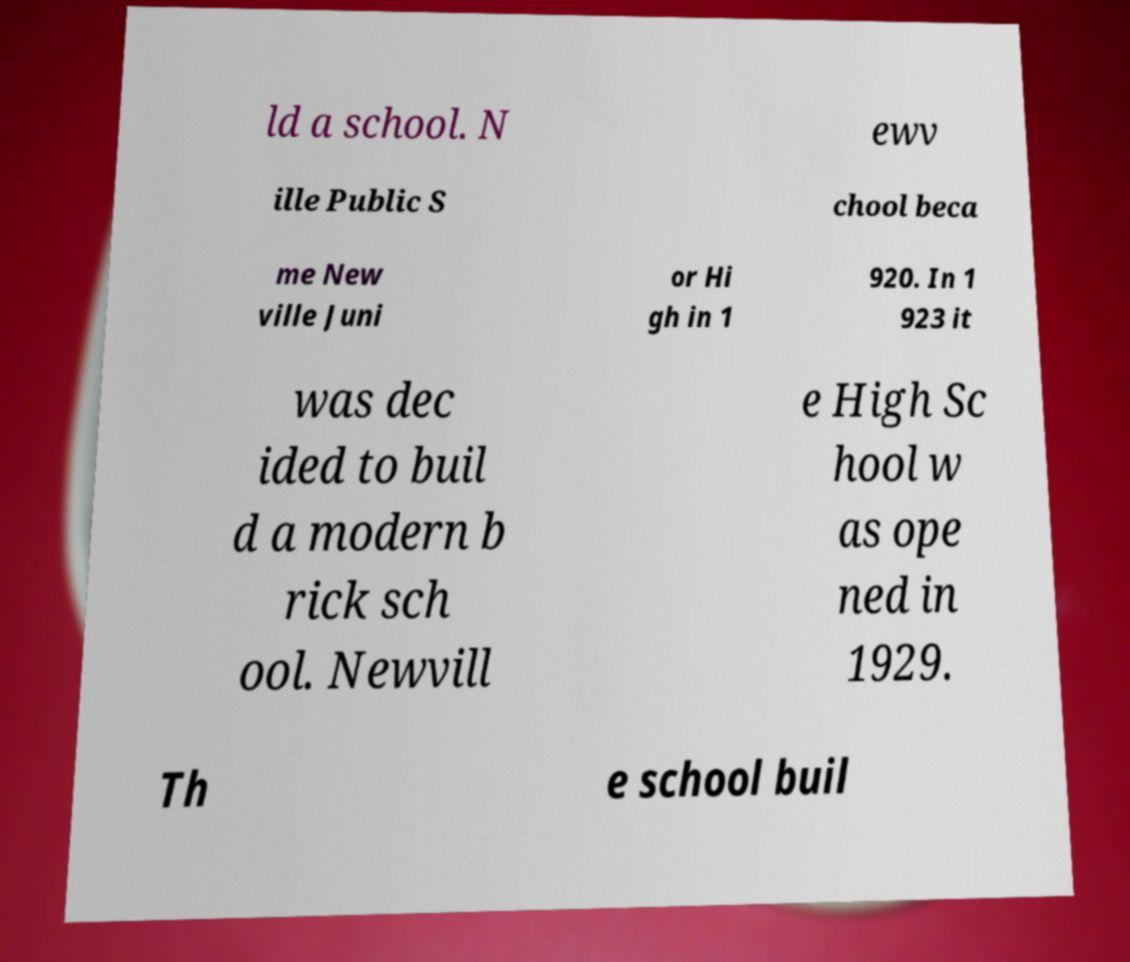For documentation purposes, I need the text within this image transcribed. Could you provide that? ld a school. N ewv ille Public S chool beca me New ville Juni or Hi gh in 1 920. In 1 923 it was dec ided to buil d a modern b rick sch ool. Newvill e High Sc hool w as ope ned in 1929. Th e school buil 